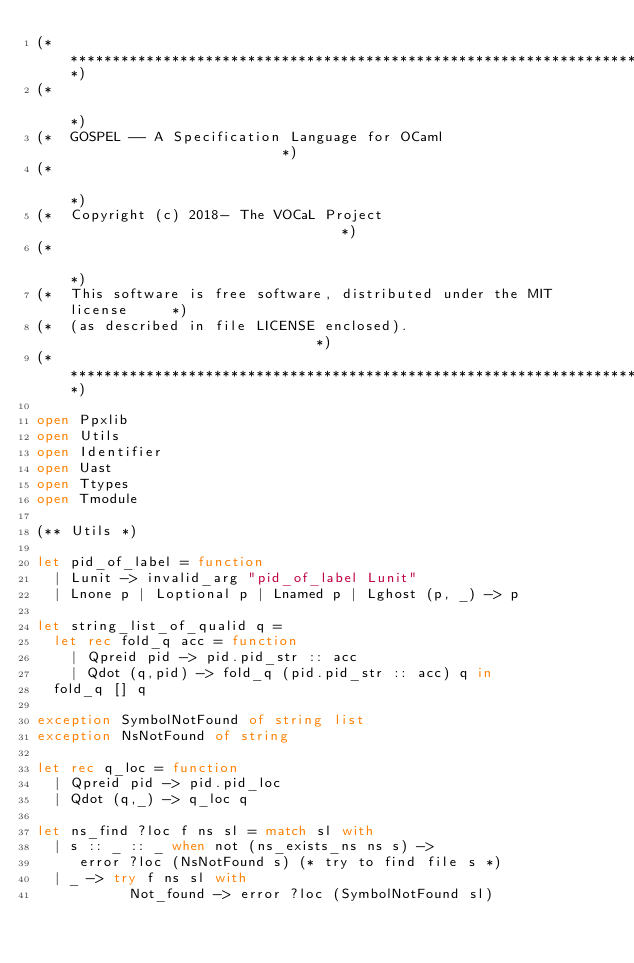Convert code to text. <code><loc_0><loc_0><loc_500><loc_500><_OCaml_>(**************************************************************************)
(*                                                                        *)
(*  GOSPEL -- A Specification Language for OCaml                          *)
(*                                                                        *)
(*  Copyright (c) 2018- The VOCaL Project                                 *)
(*                                                                        *)
(*  This software is free software, distributed under the MIT license     *)
(*  (as described in file LICENSE enclosed).                              *)
(**************************************************************************)

open Ppxlib
open Utils
open Identifier
open Uast
open Ttypes
open Tmodule

(** Utils *)

let pid_of_label = function
  | Lunit -> invalid_arg "pid_of_label Lunit"
  | Lnone p | Loptional p | Lnamed p | Lghost (p, _) -> p

let string_list_of_qualid q =
  let rec fold_q acc = function
    | Qpreid pid -> pid.pid_str :: acc
    | Qdot (q,pid) -> fold_q (pid.pid_str :: acc) q in
  fold_q [] q

exception SymbolNotFound of string list
exception NsNotFound of string

let rec q_loc = function
  | Qpreid pid -> pid.pid_loc
  | Qdot (q,_) -> q_loc q

let ns_find ?loc f ns sl = match sl with
  | s :: _ :: _ when not (ns_exists_ns ns s) ->
     error ?loc (NsNotFound s) (* try to find file s *)
  | _ -> try f ns sl with
           Not_found -> error ?loc (SymbolNotFound sl)
</code> 